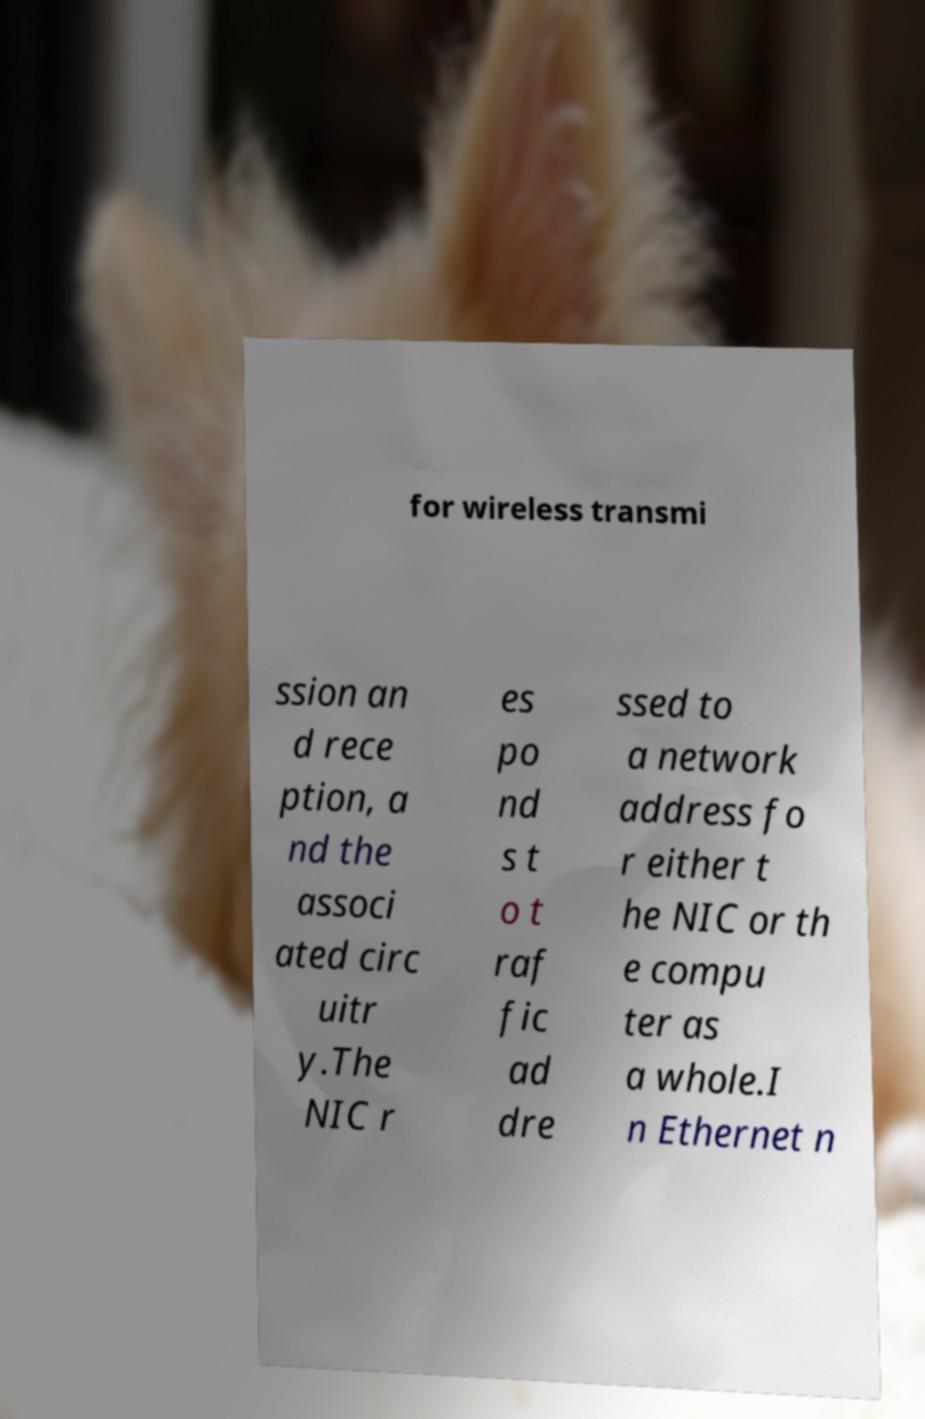I need the written content from this picture converted into text. Can you do that? for wireless transmi ssion an d rece ption, a nd the associ ated circ uitr y.The NIC r es po nd s t o t raf fic ad dre ssed to a network address fo r either t he NIC or th e compu ter as a whole.I n Ethernet n 